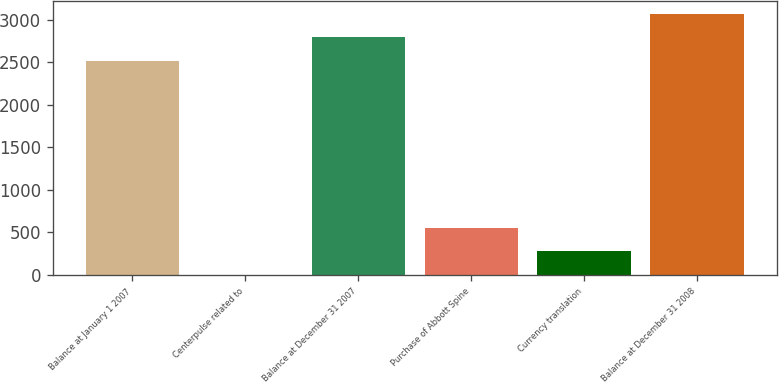<chart> <loc_0><loc_0><loc_500><loc_500><bar_chart><fcel>Balance at January 1 2007<fcel>Centerpulse related to<fcel>Balance at December 31 2007<fcel>Purchase of Abbott Spine<fcel>Currency translation<fcel>Balance at December 31 2008<nl><fcel>2515.6<fcel>1.2<fcel>2792.96<fcel>555.92<fcel>278.56<fcel>3070.32<nl></chart> 